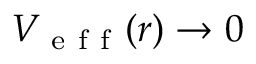<formula> <loc_0><loc_0><loc_500><loc_500>V _ { e f f } ( r ) \rightarrow 0</formula> 